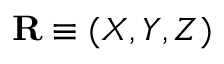Convert formula to latex. <formula><loc_0><loc_0><loc_500><loc_500>R \equiv ( X , Y , Z )</formula> 